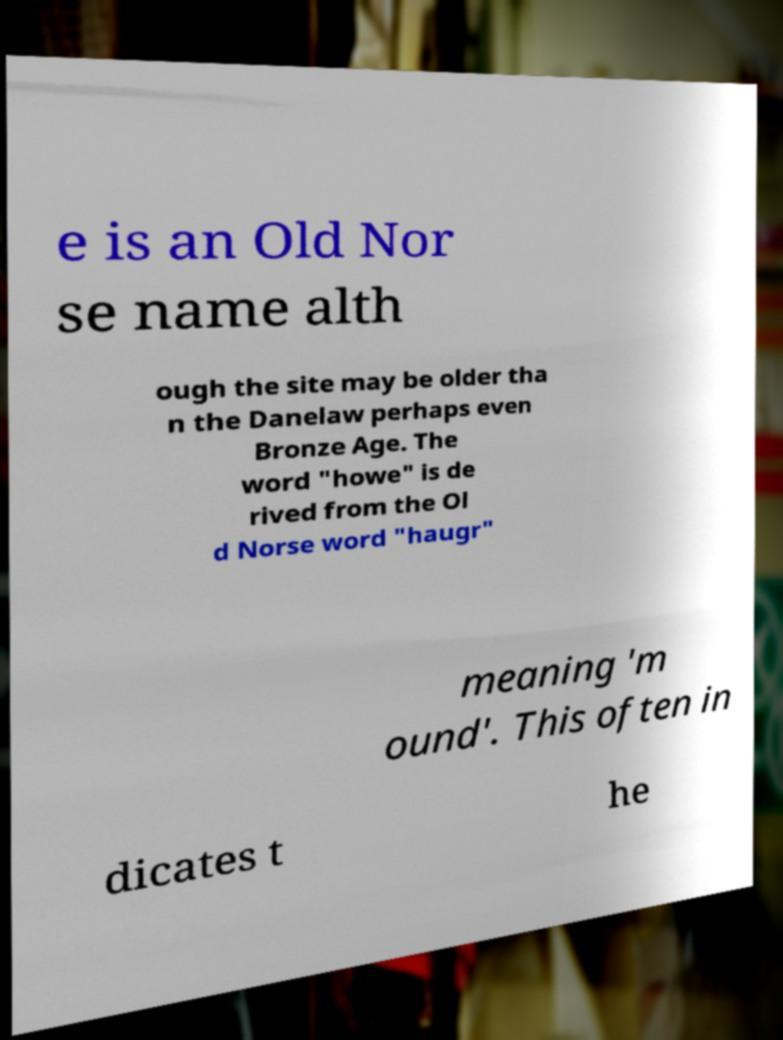Please read and relay the text visible in this image. What does it say? e is an Old Nor se name alth ough the site may be older tha n the Danelaw perhaps even Bronze Age. The word "howe" is de rived from the Ol d Norse word "haugr" meaning 'm ound'. This often in dicates t he 